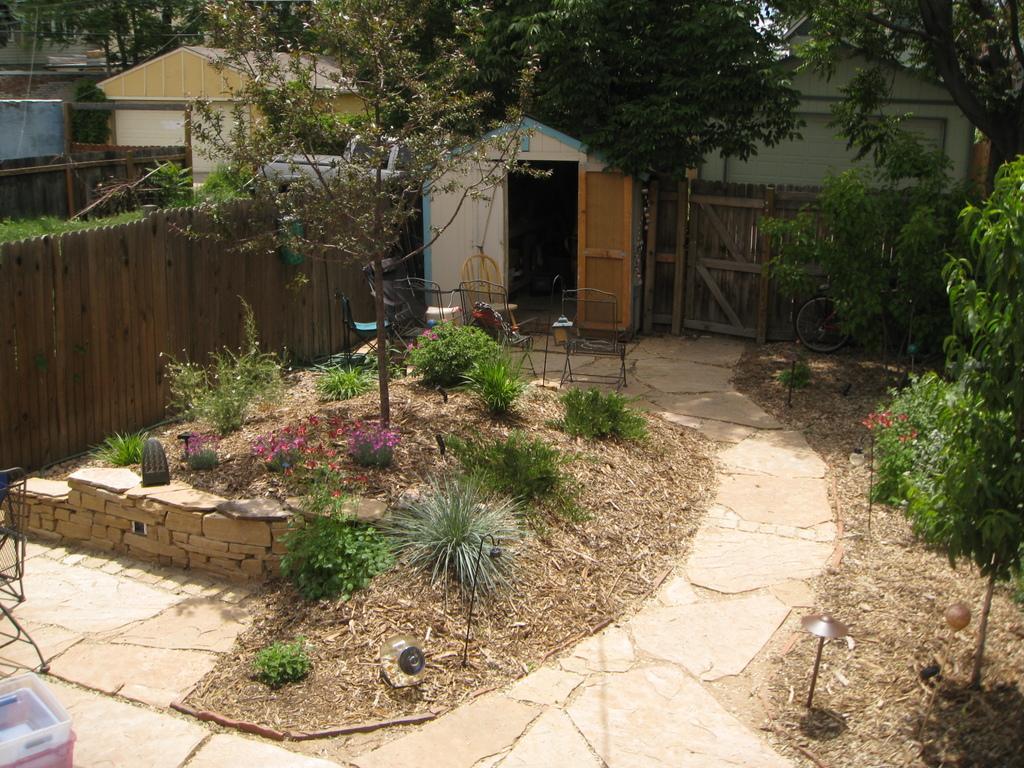Can you describe this image briefly? In this image we can see some houses with roof and a door. We can also see wooden fence, a bicycle placed aside, some chairs, tables, some plants with flowers, trees, containers, poles and a pathway. 